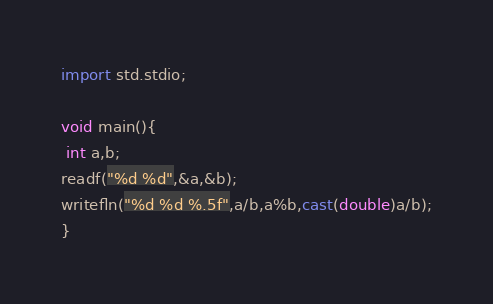<code> <loc_0><loc_0><loc_500><loc_500><_D_>import std.stdio;

void main(){
 int a,b;
readf("%d %d",&a,&b);
writefln("%d %d %.5f",a/b,a%b,cast(double)a/b);
}</code> 